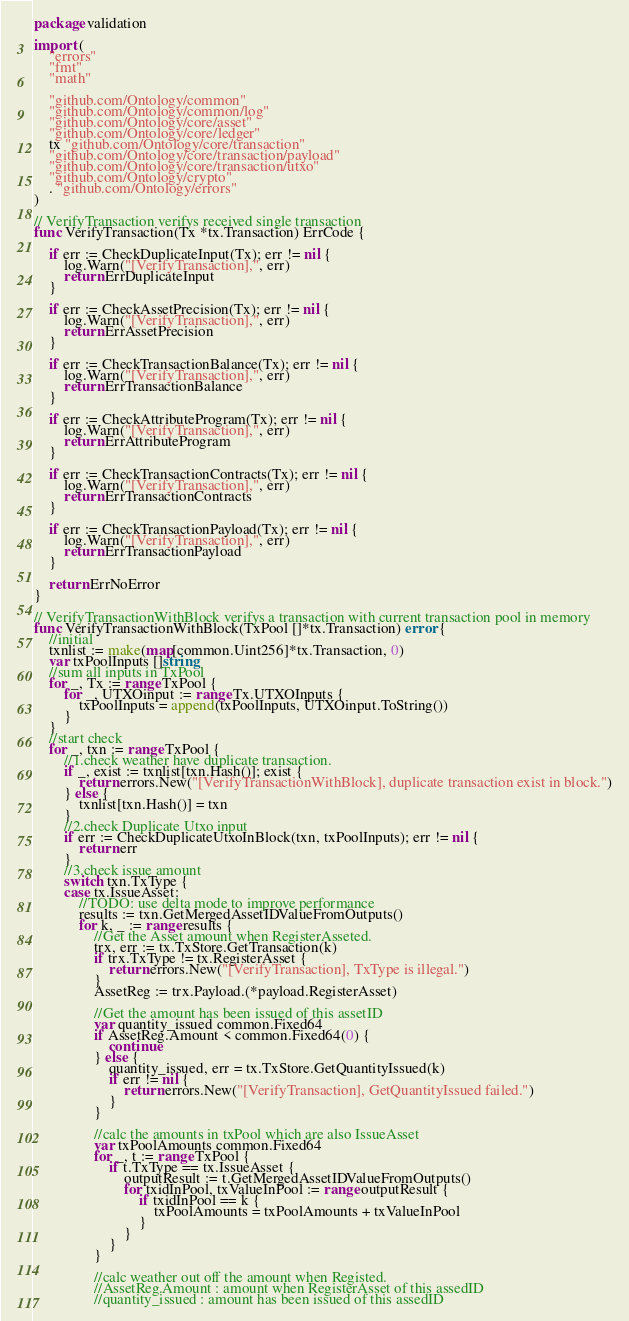Convert code to text. <code><loc_0><loc_0><loc_500><loc_500><_Go_>package validation

import (
	"errors"
	"fmt"
	"math"

	"github.com/Ontology/common"
	"github.com/Ontology/common/log"
	"github.com/Ontology/core/asset"
	"github.com/Ontology/core/ledger"
	tx "github.com/Ontology/core/transaction"
	"github.com/Ontology/core/transaction/payload"
	"github.com/Ontology/core/transaction/utxo"
	"github.com/Ontology/crypto"
	. "github.com/Ontology/errors"
)

// VerifyTransaction verifys received single transaction
func VerifyTransaction(Tx *tx.Transaction) ErrCode {

	if err := CheckDuplicateInput(Tx); err != nil {
		log.Warn("[VerifyTransaction],", err)
		return ErrDuplicateInput
	}

	if err := CheckAssetPrecision(Tx); err != nil {
		log.Warn("[VerifyTransaction],", err)
		return ErrAssetPrecision
	}

	if err := CheckTransactionBalance(Tx); err != nil {
		log.Warn("[VerifyTransaction],", err)
		return ErrTransactionBalance
	}

	if err := CheckAttributeProgram(Tx); err != nil {
		log.Warn("[VerifyTransaction],", err)
		return ErrAttributeProgram
	}

	if err := CheckTransactionContracts(Tx); err != nil {
		log.Warn("[VerifyTransaction],", err)
		return ErrTransactionContracts
	}

	if err := CheckTransactionPayload(Tx); err != nil {
		log.Warn("[VerifyTransaction],", err)
		return ErrTransactionPayload
	}

	return ErrNoError
}

// VerifyTransactionWithBlock verifys a transaction with current transaction pool in memory
func VerifyTransactionWithBlock(TxPool []*tx.Transaction) error {
	//initial
	txnlist := make(map[common.Uint256]*tx.Transaction, 0)
	var txPoolInputs []string
	//sum all inputs in TxPool
	for _, Tx := range TxPool {
		for _, UTXOinput := range Tx.UTXOInputs {
			txPoolInputs = append(txPoolInputs, UTXOinput.ToString())
		}
	}
	//start check
	for _, txn := range TxPool {
		//1.check weather have duplicate transaction.
		if _, exist := txnlist[txn.Hash()]; exist {
			return errors.New("[VerifyTransactionWithBlock], duplicate transaction exist in block.")
		} else {
			txnlist[txn.Hash()] = txn
		}
		//2.check Duplicate Utxo input
		if err := CheckDuplicateUtxoInBlock(txn, txPoolInputs); err != nil {
			return err
		}
		//3.check issue amount
		switch txn.TxType {
		case tx.IssueAsset:
			//TODO: use delta mode to improve performance
			results := txn.GetMergedAssetIDValueFromOutputs()
			for k, _ := range results {
				//Get the Asset amount when RegisterAsseted.
				trx, err := tx.TxStore.GetTransaction(k)
				if trx.TxType != tx.RegisterAsset {
					return errors.New("[VerifyTransaction], TxType is illegal.")
				}
				AssetReg := trx.Payload.(*payload.RegisterAsset)

				//Get the amount has been issued of this assetID
				var quantity_issued common.Fixed64
				if AssetReg.Amount < common.Fixed64(0) {
					continue
				} else {
					quantity_issued, err = tx.TxStore.GetQuantityIssued(k)
					if err != nil {
						return errors.New("[VerifyTransaction], GetQuantityIssued failed.")
					}
				}

				//calc the amounts in txPool which are also IssueAsset
				var txPoolAmounts common.Fixed64
				for _, t := range TxPool {
					if t.TxType == tx.IssueAsset {
						outputResult := t.GetMergedAssetIDValueFromOutputs()
						for txidInPool, txValueInPool := range outputResult {
							if txidInPool == k {
								txPoolAmounts = txPoolAmounts + txValueInPool
							}
						}
					}
				}

				//calc weather out off the amount when Registed.
				//AssetReg.Amount : amount when RegisterAsset of this assedID
				//quantity_issued : amount has been issued of this assedID</code> 